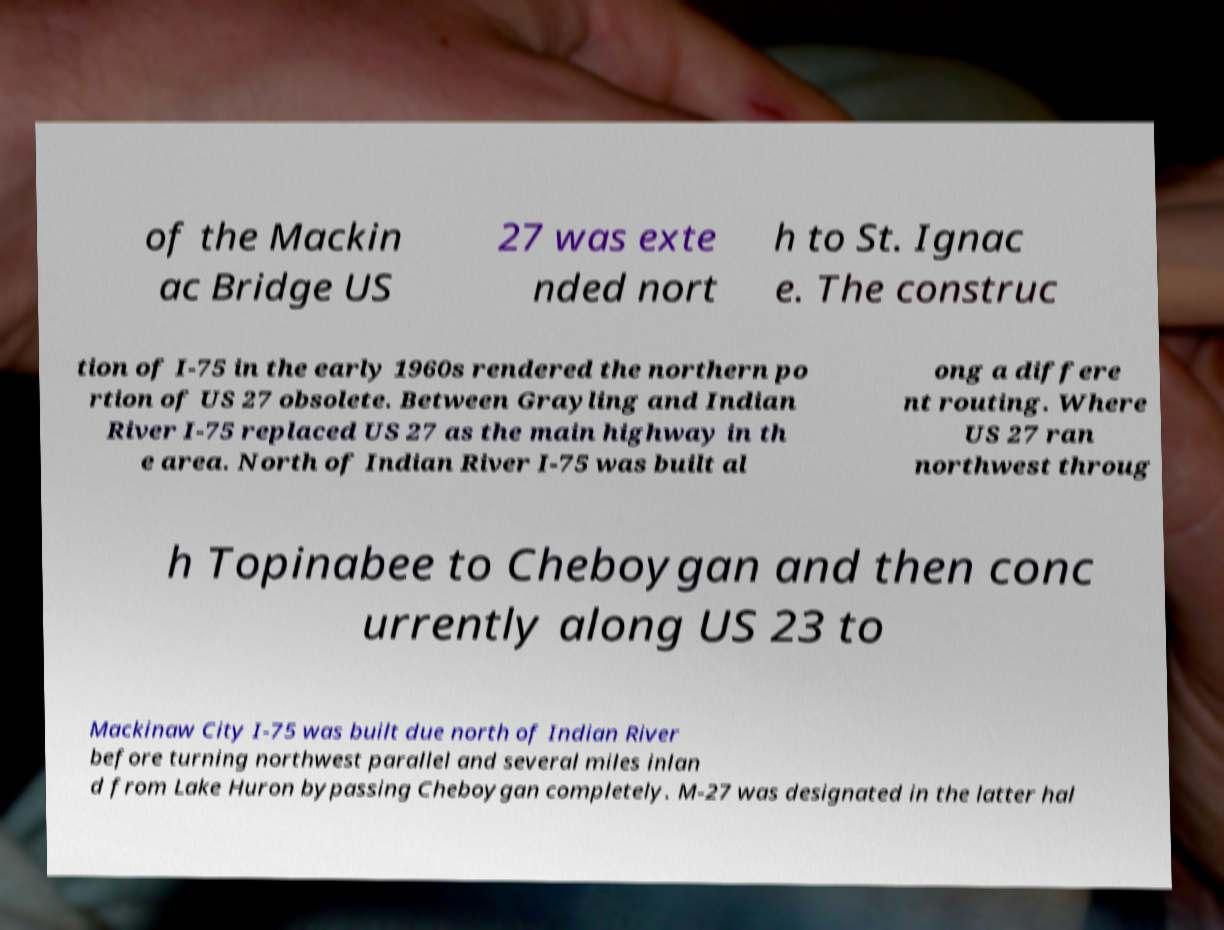Please identify and transcribe the text found in this image. of the Mackin ac Bridge US 27 was exte nded nort h to St. Ignac e. The construc tion of I-75 in the early 1960s rendered the northern po rtion of US 27 obsolete. Between Grayling and Indian River I-75 replaced US 27 as the main highway in th e area. North of Indian River I-75 was built al ong a differe nt routing. Where US 27 ran northwest throug h Topinabee to Cheboygan and then conc urrently along US 23 to Mackinaw City I-75 was built due north of Indian River before turning northwest parallel and several miles inlan d from Lake Huron bypassing Cheboygan completely. M-27 was designated in the latter hal 